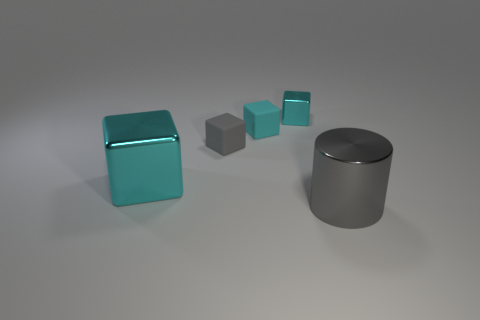What size is the gray cylinder that is made of the same material as the large cyan block?
Your answer should be very brief. Large. What is the material of the tiny gray thing that is the same shape as the large cyan shiny thing?
Offer a terse response. Rubber. How many other things are there of the same shape as the gray shiny object?
Provide a short and direct response. 0. Is the color of the cylinder the same as the small metal object?
Your response must be concise. No. What number of things are either gray shiny objects or cyan shiny things in front of the cyan matte block?
Your answer should be very brief. 2. Is there a gray matte object that has the same size as the cyan rubber block?
Your response must be concise. Yes. Do the gray cylinder and the large cube have the same material?
Your answer should be very brief. Yes. How many things are either metal objects or big blue matte cylinders?
Provide a succinct answer. 3. The cylinder has what size?
Your answer should be very brief. Large. Is the number of small rubber cylinders less than the number of small gray rubber cubes?
Provide a succinct answer. Yes. 